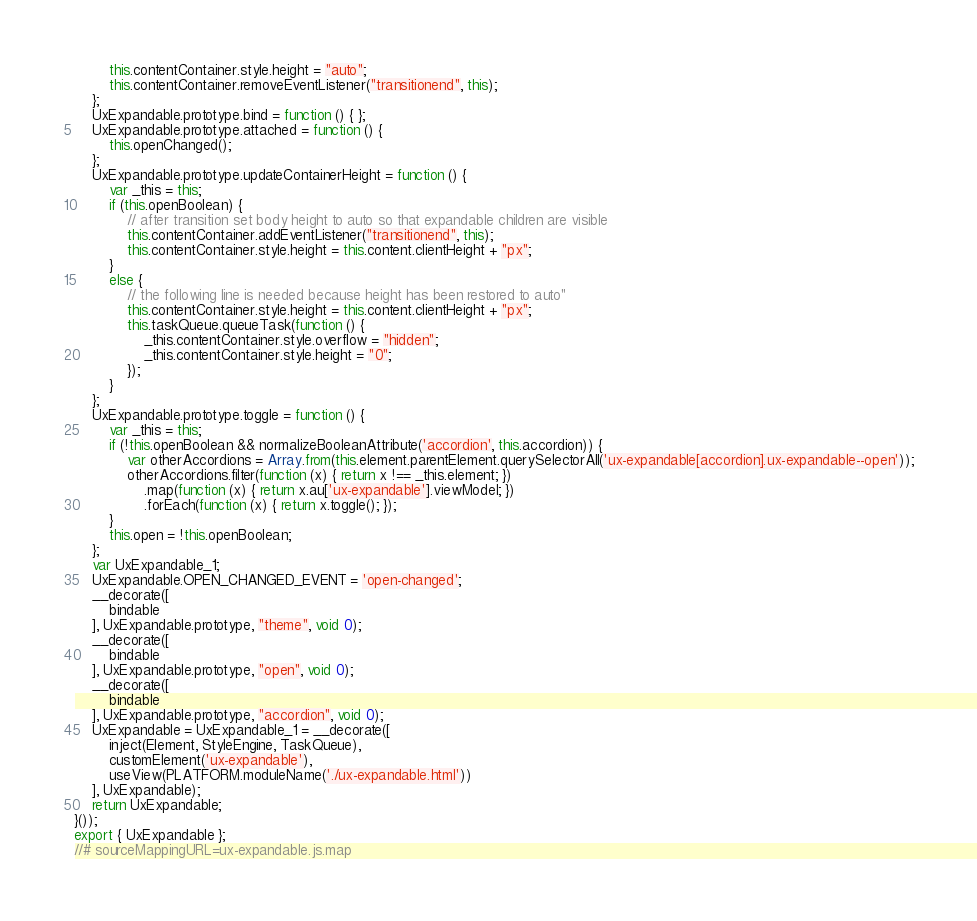Convert code to text. <code><loc_0><loc_0><loc_500><loc_500><_JavaScript_>        this.contentContainer.style.height = "auto";
        this.contentContainer.removeEventListener("transitionend", this);
    };
    UxExpandable.prototype.bind = function () { };
    UxExpandable.prototype.attached = function () {
        this.openChanged();
    };
    UxExpandable.prototype.updateContainerHeight = function () {
        var _this = this;
        if (this.openBoolean) {
            // after transition set body height to auto so that expandable children are visible
            this.contentContainer.addEventListener("transitionend", this);
            this.contentContainer.style.height = this.content.clientHeight + "px";
        }
        else {
            // the following line is needed because height has been restored to auto"
            this.contentContainer.style.height = this.content.clientHeight + "px";
            this.taskQueue.queueTask(function () {
                _this.contentContainer.style.overflow = "hidden";
                _this.contentContainer.style.height = "0";
            });
        }
    };
    UxExpandable.prototype.toggle = function () {
        var _this = this;
        if (!this.openBoolean && normalizeBooleanAttribute('accordion', this.accordion)) {
            var otherAccordions = Array.from(this.element.parentElement.querySelectorAll('ux-expandable[accordion].ux-expandable--open'));
            otherAccordions.filter(function (x) { return x !== _this.element; })
                .map(function (x) { return x.au['ux-expandable'].viewModel; })
                .forEach(function (x) { return x.toggle(); });
        }
        this.open = !this.openBoolean;
    };
    var UxExpandable_1;
    UxExpandable.OPEN_CHANGED_EVENT = 'open-changed';
    __decorate([
        bindable
    ], UxExpandable.prototype, "theme", void 0);
    __decorate([
        bindable
    ], UxExpandable.prototype, "open", void 0);
    __decorate([
        bindable
    ], UxExpandable.prototype, "accordion", void 0);
    UxExpandable = UxExpandable_1 = __decorate([
        inject(Element, StyleEngine, TaskQueue),
        customElement('ux-expandable'),
        useView(PLATFORM.moduleName('./ux-expandable.html'))
    ], UxExpandable);
    return UxExpandable;
}());
export { UxExpandable };
//# sourceMappingURL=ux-expandable.js.map</code> 